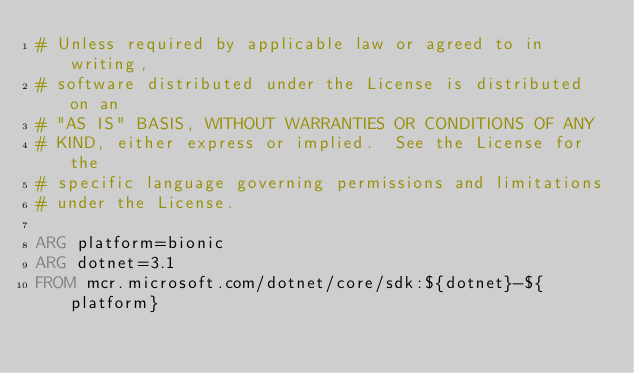<code> <loc_0><loc_0><loc_500><loc_500><_Dockerfile_># Unless required by applicable law or agreed to in writing,
# software distributed under the License is distributed on an
# "AS IS" BASIS, WITHOUT WARRANTIES OR CONDITIONS OF ANY
# KIND, either express or implied.  See the License for the
# specific language governing permissions and limitations
# under the License.

ARG platform=bionic
ARG dotnet=3.1
FROM mcr.microsoft.com/dotnet/core/sdk:${dotnet}-${platform}
</code> 